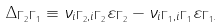Convert formula to latex. <formula><loc_0><loc_0><loc_500><loc_500>\Delta _ { \Gamma _ { 2 } \Gamma _ { 1 } } \equiv \nu _ { i \Gamma _ { 2 } , i \Gamma _ { 2 } } \varepsilon _ { \Gamma _ { 2 } } - \nu _ { i \Gamma _ { 1 } , i \Gamma _ { 1 } } \varepsilon _ { \Gamma _ { 1 } . }</formula> 